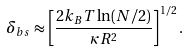Convert formula to latex. <formula><loc_0><loc_0><loc_500><loc_500>\delta _ { b s } \approx \left [ \frac { 2 k _ { B } T \ln ( N / 2 ) } { \kappa R ^ { 2 } } \right ] ^ { 1 / 2 } .</formula> 